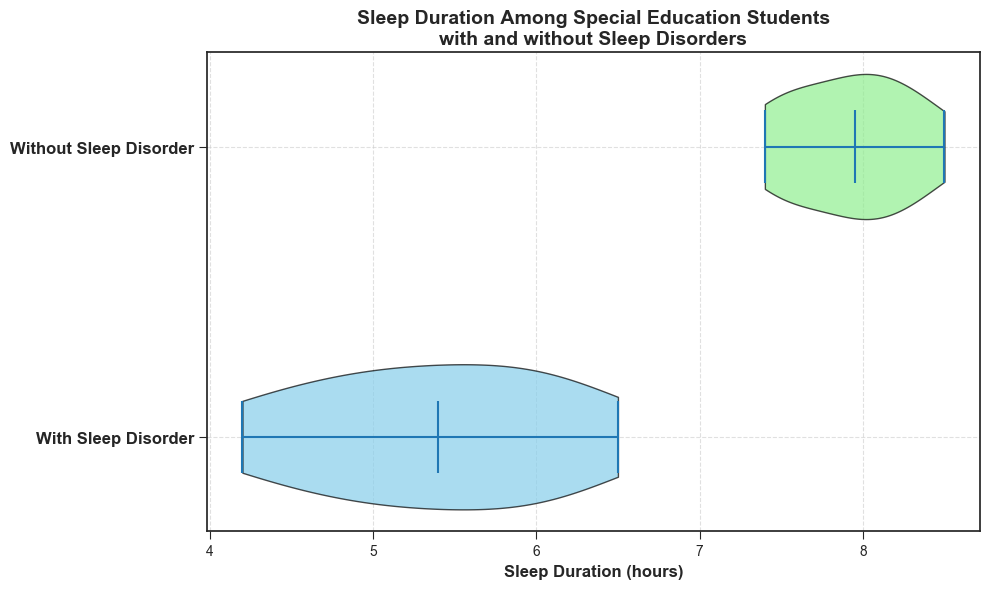What's the median Sleep Duration for students with Sleep Disorders? The median is represented by the white dot in the violin plot. For students with sleep disorders, this dot is positioned close to 5.5 hours.
Answer: 5.5 hours Which group shows a wider distribution in Sleep Duration? The width of the violin plot indicates the distribution. The group "Without Sleep Disorder" has a visibly wider violin plot, showing more variability in sleep duration.
Answer: Without Sleep Disorder What's the difference between the medians of the two groups? The median for students with sleep disorders is 5.5 hours, while for those without sleep disorders, it is around 8 hours. The difference is 8 - 5.5 = 2.5 hours.
Answer: 2.5 hours Which group has the higher median Sleep Duration? The median is represented by the white dot. The "Without Sleep Disorder" group has the higher median, positioned at around 8 hours.
Answer: Without Sleep Disorder Is the majority of Sleep Duration data for students without sleep disorders more concentrated than students with sleep disorders? The "Without Sleep Disorder" group has a fuller shape around the median, indicating that most of the data points are concentrated around the median. This suggests less variability compared to the more spread-out shape for the "With Sleep Disorder" group.
Answer: Yes Are there any Sleep Duration values below 5 hours for the "Without Sleep Disorder" group? The violin plot for the "Without Sleep Disorder" group does not extend below 5 hours. This indicates that there are no sleep duration values below 5 hours for this group.
Answer: No What's the approximate interquartile range for the "With Sleep Disorder" group? The interquartile range can be approximated by the spread between the first quartile and the third quartile on the violin plot. For the "With Sleep Disorder" group, this range appears to be from about 4.5 to 6 hours, so the approximate interquartile range is 6 - 4.5 = 1.5 hours.
Answer: 1.5 hours 